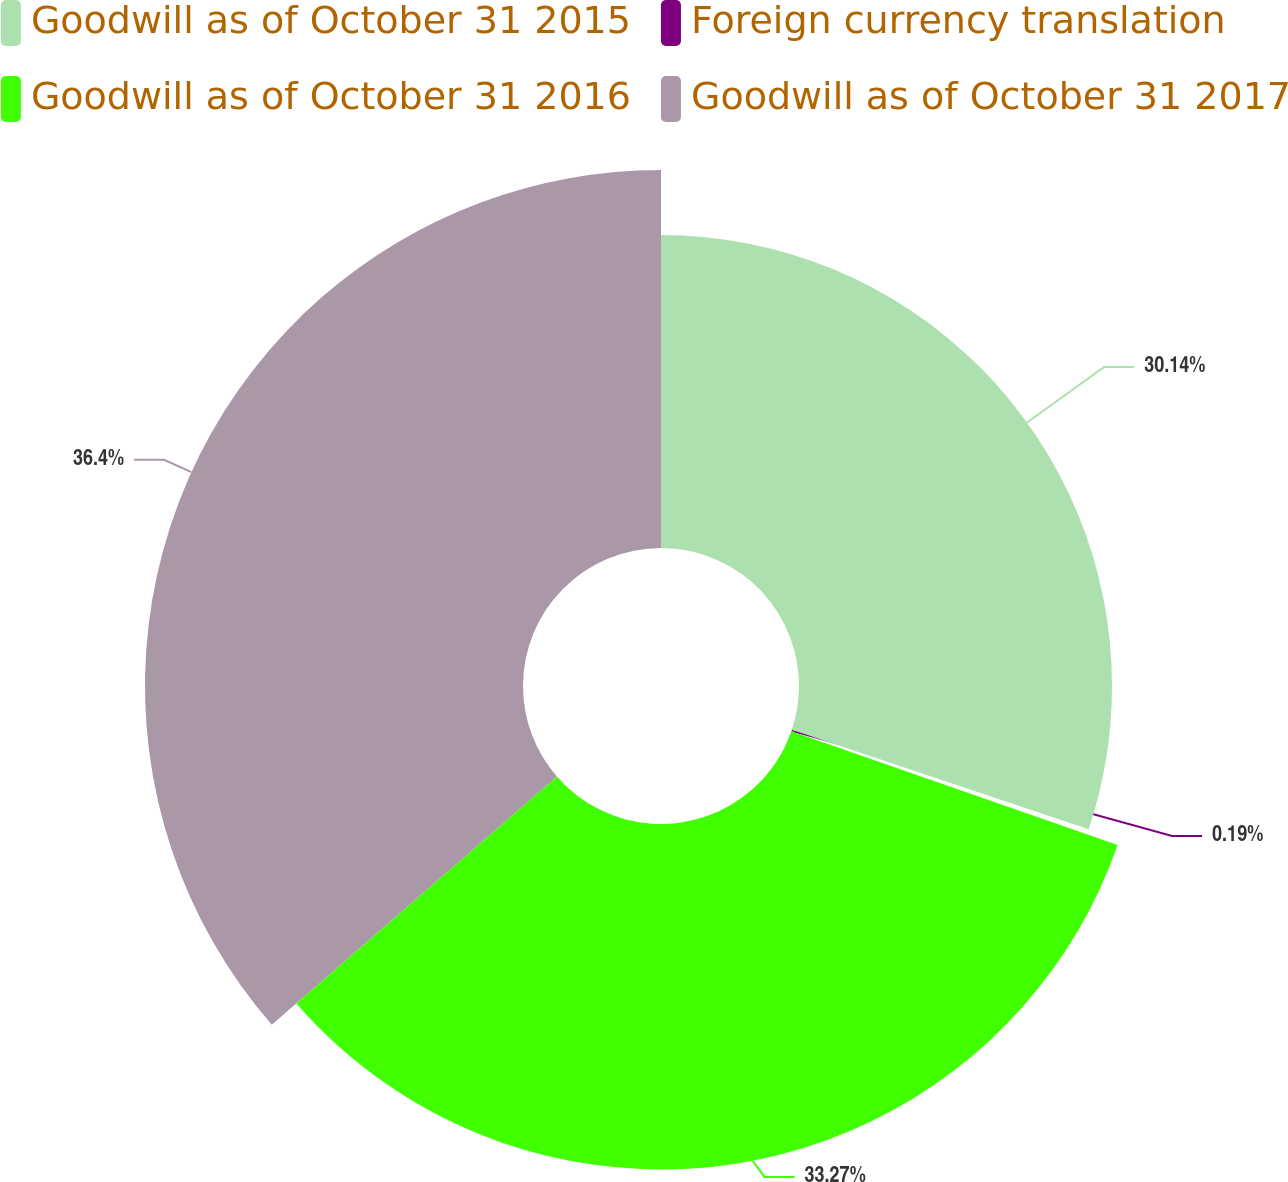Convert chart. <chart><loc_0><loc_0><loc_500><loc_500><pie_chart><fcel>Goodwill as of October 31 2015<fcel>Foreign currency translation<fcel>Goodwill as of October 31 2016<fcel>Goodwill as of October 31 2017<nl><fcel>30.14%<fcel>0.19%<fcel>33.27%<fcel>36.4%<nl></chart> 